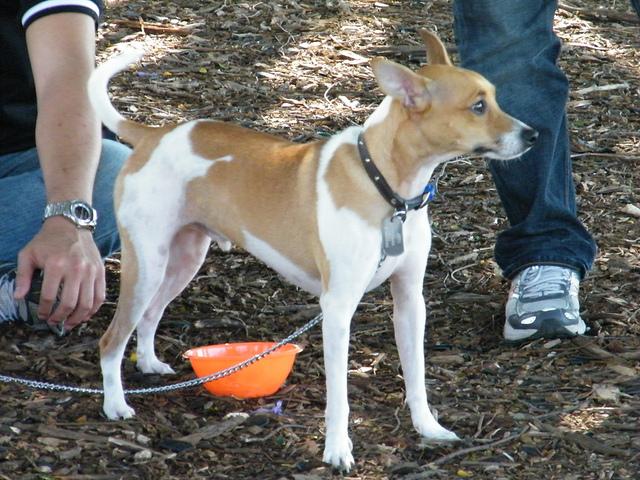How many dogs are shown?
Give a very brief answer. 1. What kind of animal is this?
Be succinct. Dog. What is the person on the left wearing on their arm?
Keep it brief. Watch. 